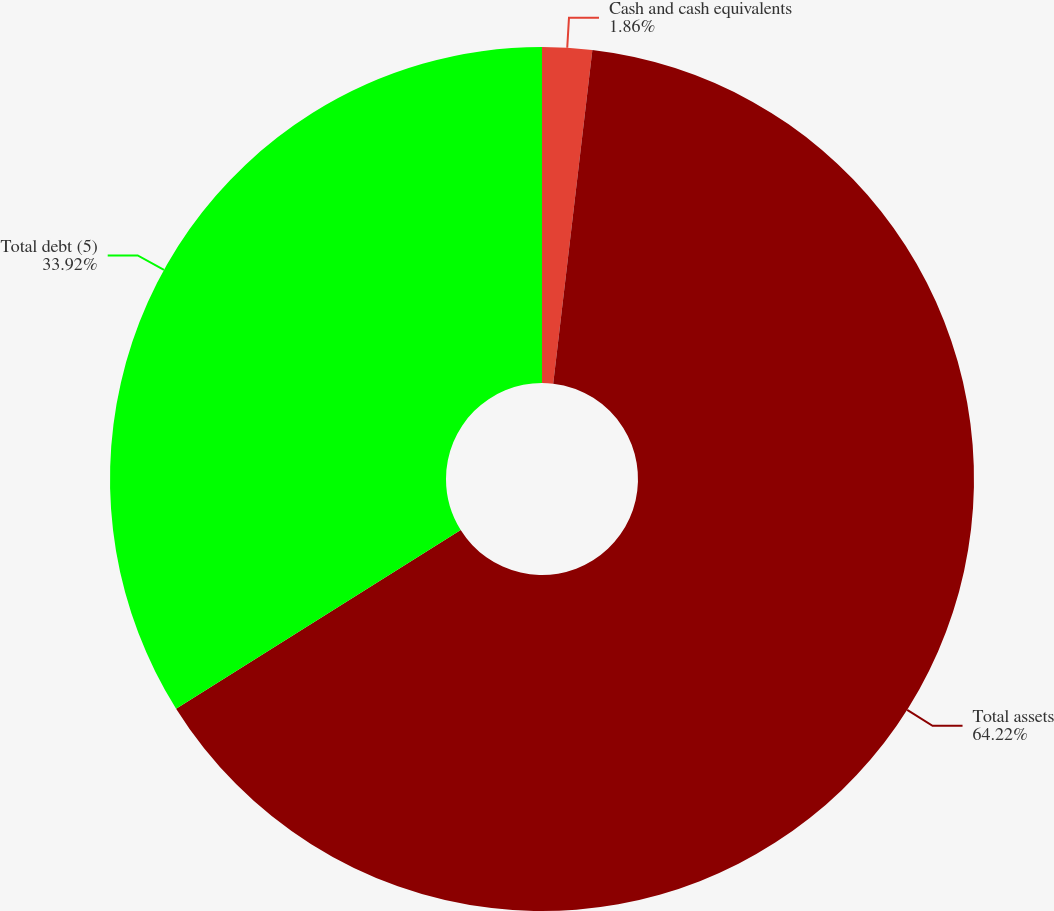<chart> <loc_0><loc_0><loc_500><loc_500><pie_chart><fcel>Cash and cash equivalents<fcel>Total assets<fcel>Total debt (5)<nl><fcel>1.86%<fcel>64.22%<fcel>33.92%<nl></chart> 